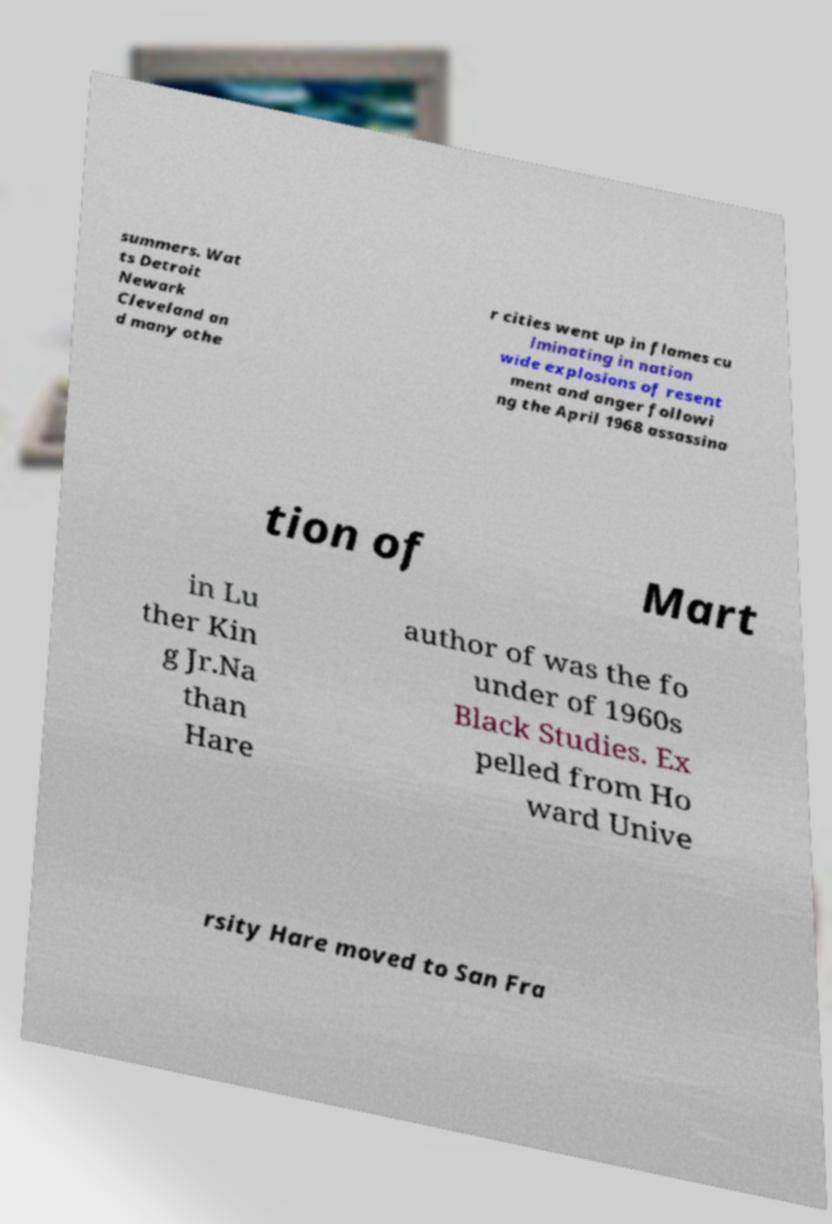Can you read and provide the text displayed in the image?This photo seems to have some interesting text. Can you extract and type it out for me? summers. Wat ts Detroit Newark Cleveland an d many othe r cities went up in flames cu lminating in nation wide explosions of resent ment and anger followi ng the April 1968 assassina tion of Mart in Lu ther Kin g Jr.Na than Hare author of was the fo under of 1960s Black Studies. Ex pelled from Ho ward Unive rsity Hare moved to San Fra 